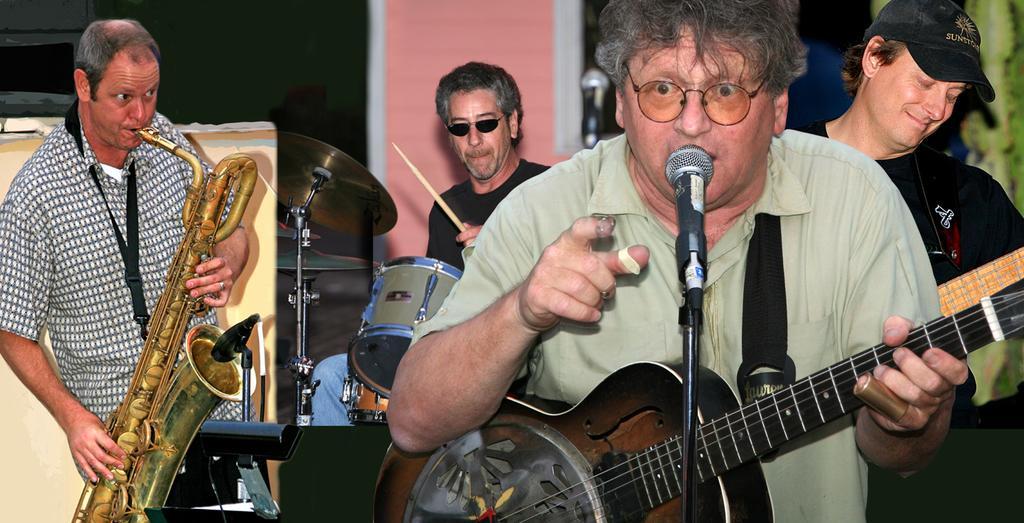Can you describe this image briefly? In this picture we can see four persons playing musical instruments such as guitar, drums, saxophone and here man singing on mic and in background we can see wall. 